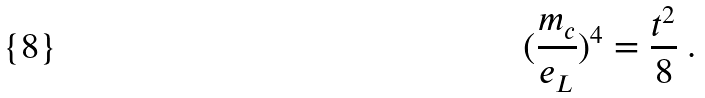Convert formula to latex. <formula><loc_0><loc_0><loc_500><loc_500>( \frac { m _ { c } } { e _ { L } } ) ^ { 4 } = \frac { t ^ { 2 } } { 8 } \ .</formula> 